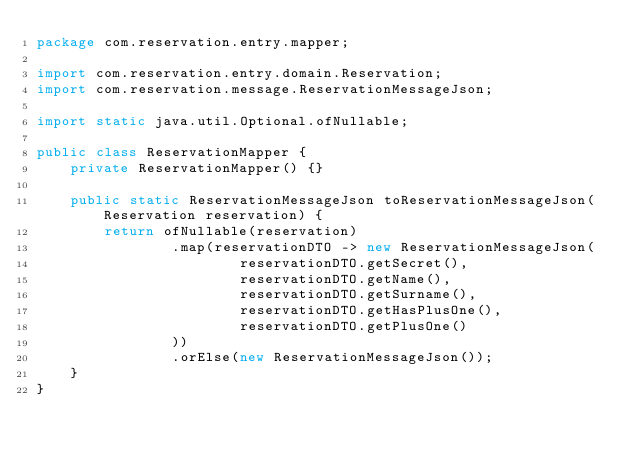<code> <loc_0><loc_0><loc_500><loc_500><_Java_>package com.reservation.entry.mapper;

import com.reservation.entry.domain.Reservation;
import com.reservation.message.ReservationMessageJson;

import static java.util.Optional.ofNullable;

public class ReservationMapper {
    private ReservationMapper() {}

    public static ReservationMessageJson toReservationMessageJson(Reservation reservation) {
        return ofNullable(reservation)
                .map(reservationDTO -> new ReservationMessageJson(
                        reservationDTO.getSecret(),
                        reservationDTO.getName(),
                        reservationDTO.getSurname(),
                        reservationDTO.getHasPlusOne(),
                        reservationDTO.getPlusOne()
                ))
                .orElse(new ReservationMessageJson());
    }
}
</code> 